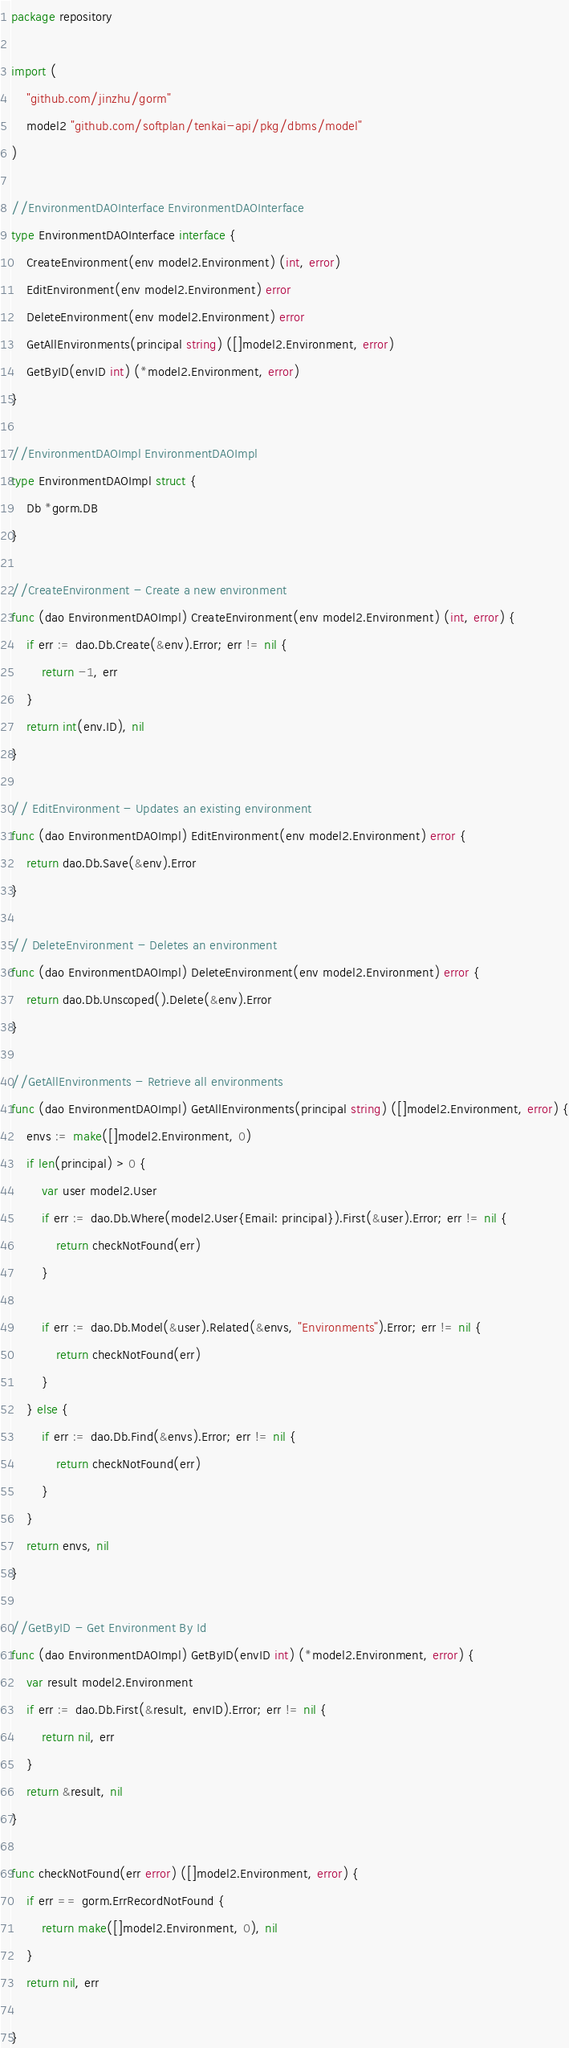Convert code to text. <code><loc_0><loc_0><loc_500><loc_500><_Go_>package repository

import (
	"github.com/jinzhu/gorm"
	model2 "github.com/softplan/tenkai-api/pkg/dbms/model"
)

//EnvironmentDAOInterface EnvironmentDAOInterface
type EnvironmentDAOInterface interface {
	CreateEnvironment(env model2.Environment) (int, error)
	EditEnvironment(env model2.Environment) error
	DeleteEnvironment(env model2.Environment) error
	GetAllEnvironments(principal string) ([]model2.Environment, error)
	GetByID(envID int) (*model2.Environment, error)
}

//EnvironmentDAOImpl EnvironmentDAOImpl
type EnvironmentDAOImpl struct {
	Db *gorm.DB
}

//CreateEnvironment - Create a new environment
func (dao EnvironmentDAOImpl) CreateEnvironment(env model2.Environment) (int, error) {
	if err := dao.Db.Create(&env).Error; err != nil {
		return -1, err
	}
	return int(env.ID), nil
}

// EditEnvironment - Updates an existing environment
func (dao EnvironmentDAOImpl) EditEnvironment(env model2.Environment) error {
	return dao.Db.Save(&env).Error
}

// DeleteEnvironment - Deletes an environment
func (dao EnvironmentDAOImpl) DeleteEnvironment(env model2.Environment) error {
	return dao.Db.Unscoped().Delete(&env).Error
}

//GetAllEnvironments - Retrieve all environments
func (dao EnvironmentDAOImpl) GetAllEnvironments(principal string) ([]model2.Environment, error) {
	envs := make([]model2.Environment, 0)
	if len(principal) > 0 {
		var user model2.User
		if err := dao.Db.Where(model2.User{Email: principal}).First(&user).Error; err != nil {
			return checkNotFound(err)
		}

		if err := dao.Db.Model(&user).Related(&envs, "Environments").Error; err != nil {
			return checkNotFound(err)
		}
	} else {
		if err := dao.Db.Find(&envs).Error; err != nil {
			return checkNotFound(err)
		}
	}
	return envs, nil
}

//GetByID - Get Environment By Id
func (dao EnvironmentDAOImpl) GetByID(envID int) (*model2.Environment, error) {
	var result model2.Environment
	if err := dao.Db.First(&result, envID).Error; err != nil {
		return nil, err
	}
	return &result, nil
}

func checkNotFound(err error) ([]model2.Environment, error) {
	if err == gorm.ErrRecordNotFound {
		return make([]model2.Environment, 0), nil
	}
	return nil, err

}
</code> 